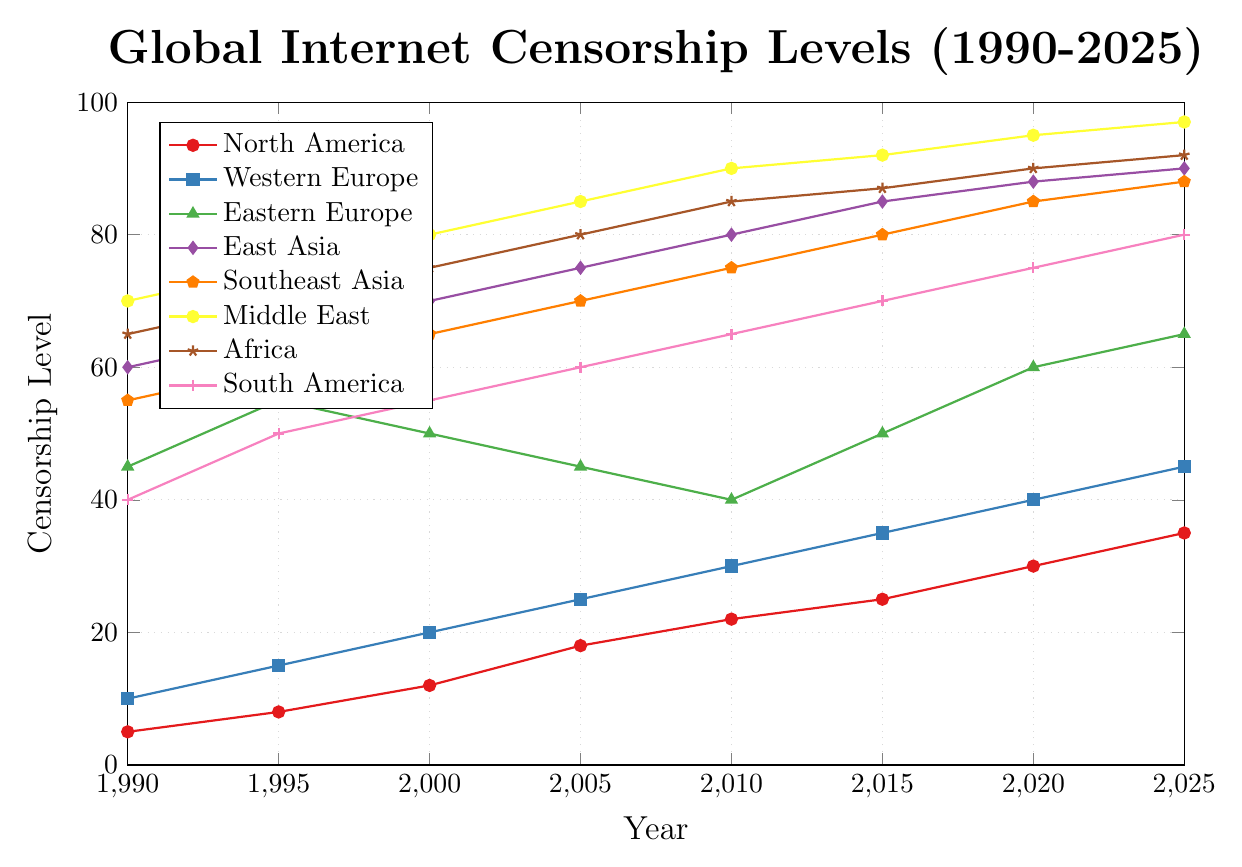Which region had the highest censorship levels in 2020? By observing the line plot and looking at the values for the year 2020, the Middle East has the highest censorship level of 95.
Answer: Middle East Which region saw the largest increase in censorship levels from 1990 to 2025? To determine the largest increase, calculate the difference between the 1990 and 2025 values for each region. The region with the greatest difference is the Middle East, with an increase of 27 (97 - 70).
Answer: Middle East How does North America's censorship level in 2025 compare to Western Europe's in 2010? Refer to the plot to find North America's censorship level in 2025 (35) and Western Europe's in 2010 (30). Compare the two values. North America in 2025 has 5 units higher censorship than Western Europe in 2010.
Answer: North America's censorship level is 5 units higher Calculate the average censorship level of East Asia from 1990 to 2000. Calculate the average of the values for East Asia for 1990, 1995, and 2000. (60 + 65 + 70) / 3 = 65.
Answer: 65 Which region had a consistent increase in censorship levels every five years from 1990 to 2025? By examining the plot, North America had a consistent increase every five years, starting from 5 in 1990 to 35 in 2025.
Answer: North America Is there any region that showed a decreasing trend in any period? By observing the plot, Eastern Europe shows a decreasing trend from 2000 to 2010 (from 50 to 40).
Answer: Yes, Eastern Europe Which regions had their censorship levels reach 85 or above by 2025? By observing the values in 2025, the regions are East Asia (90), Southeast Asia (88), Middle East (97), and Africa (92).
Answer: East Asia, Southeast Asia, Middle East, Africa Compare the changes in censorship levels between Southeast Asia and Africa from 2015 to 2020. Southeast Asia increased from 80 to 85, an increase of 5. Africa increased from 87 to 90, an increase of 3.
Answer: Southeast Asia increased by 5, Africa by 3 What can be inferred about global censorship trends from 1990 to 2025 based on the plot? Most regions show increasing trends in censorship levels over the years, with the Middle East and East Asia showing particularly high levels. This suggests a global increase in internet censorship.
Answer: Increasing global trend 